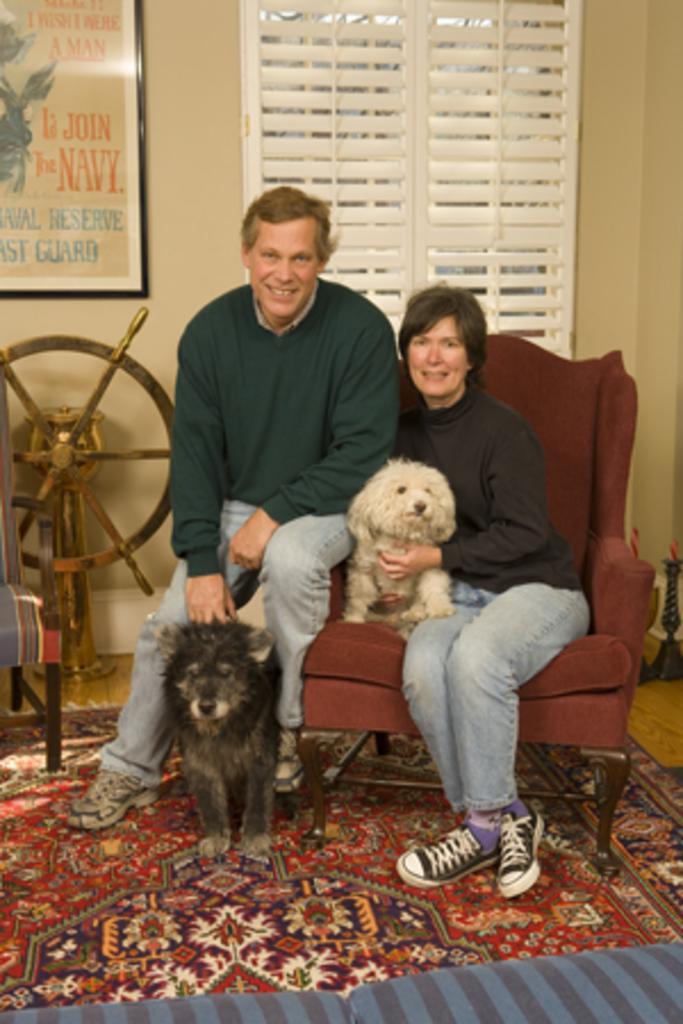Can you describe this image briefly? In this picture we can see there are two persons and dogs. On the floor there is a carpet. On the left side of the image, there is an object. Behind the people there is a window, wall and a photo frame. 